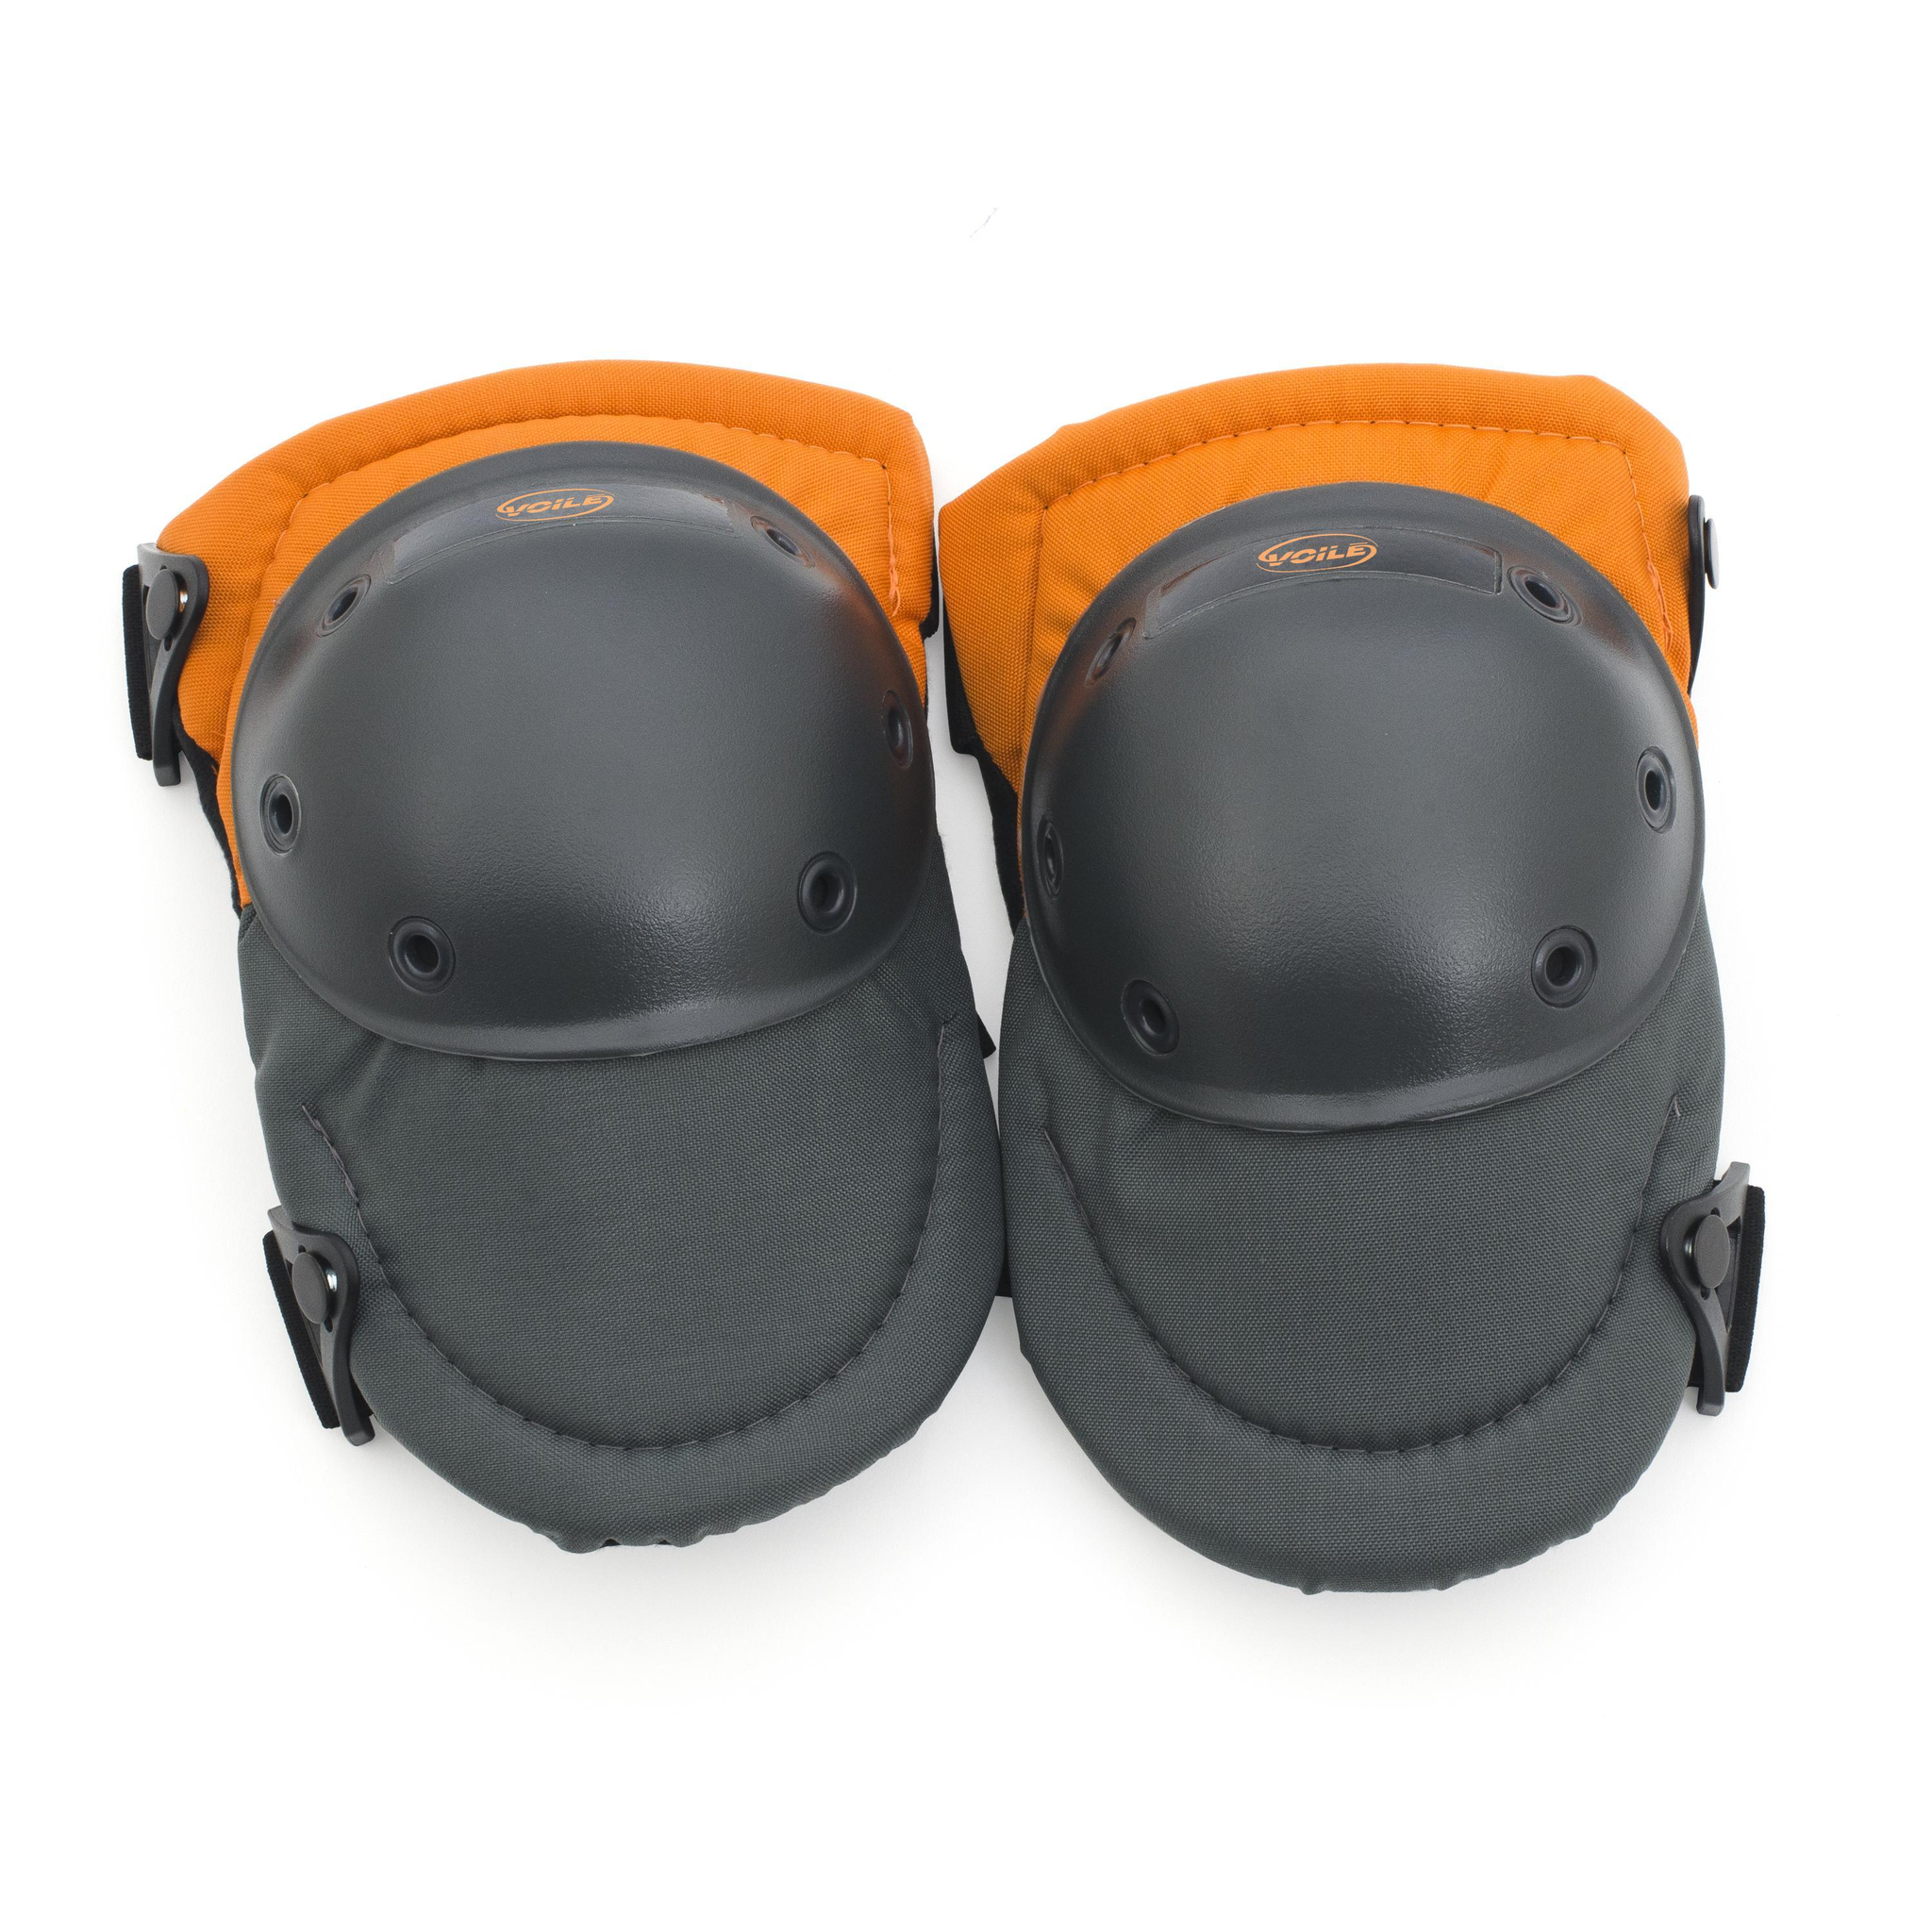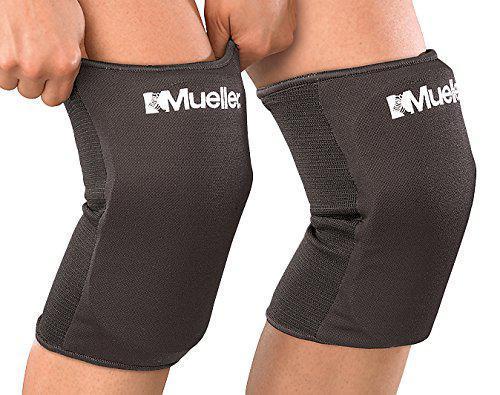The first image is the image on the left, the second image is the image on the right. Considering the images on both sides, is "The pair of pads on the left is flat on the surface, facing the camera." valid? Answer yes or no. Yes. The first image is the image on the left, the second image is the image on the right. Considering the images on both sides, is "Right image shows a pair of black kneepads turned rightward." valid? Answer yes or no. Yes. 